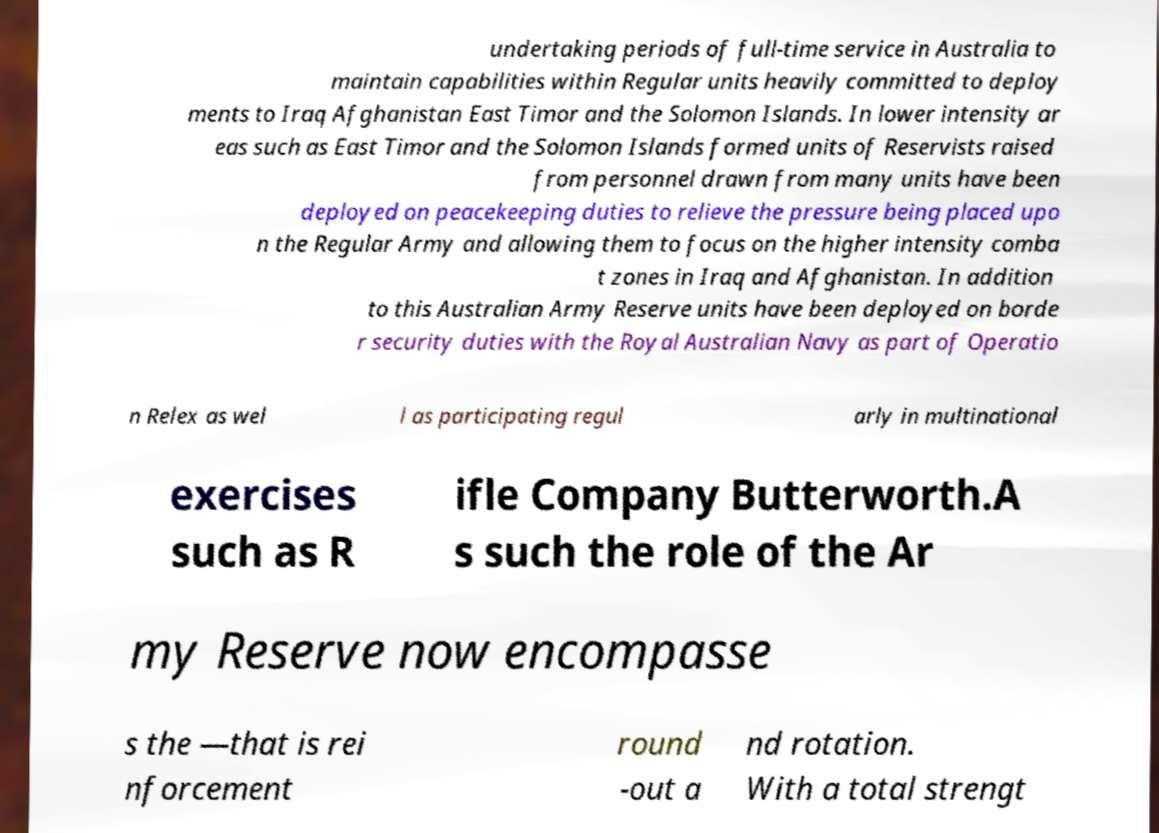There's text embedded in this image that I need extracted. Can you transcribe it verbatim? undertaking periods of full-time service in Australia to maintain capabilities within Regular units heavily committed to deploy ments to Iraq Afghanistan East Timor and the Solomon Islands. In lower intensity ar eas such as East Timor and the Solomon Islands formed units of Reservists raised from personnel drawn from many units have been deployed on peacekeeping duties to relieve the pressure being placed upo n the Regular Army and allowing them to focus on the higher intensity comba t zones in Iraq and Afghanistan. In addition to this Australian Army Reserve units have been deployed on borde r security duties with the Royal Australian Navy as part of Operatio n Relex as wel l as participating regul arly in multinational exercises such as R ifle Company Butterworth.A s such the role of the Ar my Reserve now encompasse s the —that is rei nforcement round -out a nd rotation. With a total strengt 